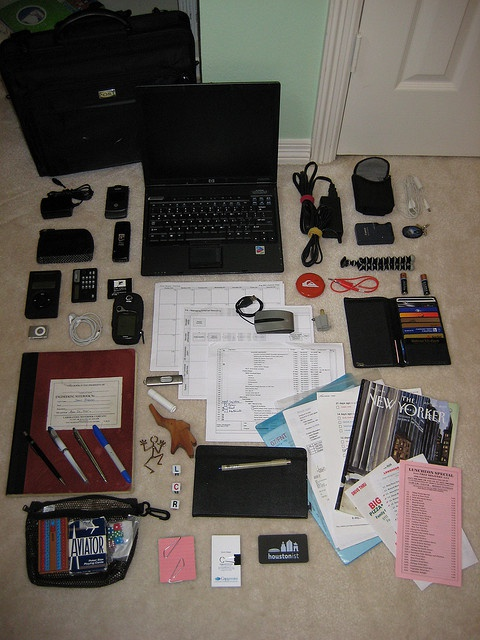Describe the objects in this image and their specific colors. I can see laptop in black, gray, darkgreen, and darkgray tones, tv in black, gray, and darkgreen tones, book in black, darkgray, gray, and lightpink tones, keyboard in black, gray, and darkgray tones, and book in black, lightgray, and darkgray tones in this image. 